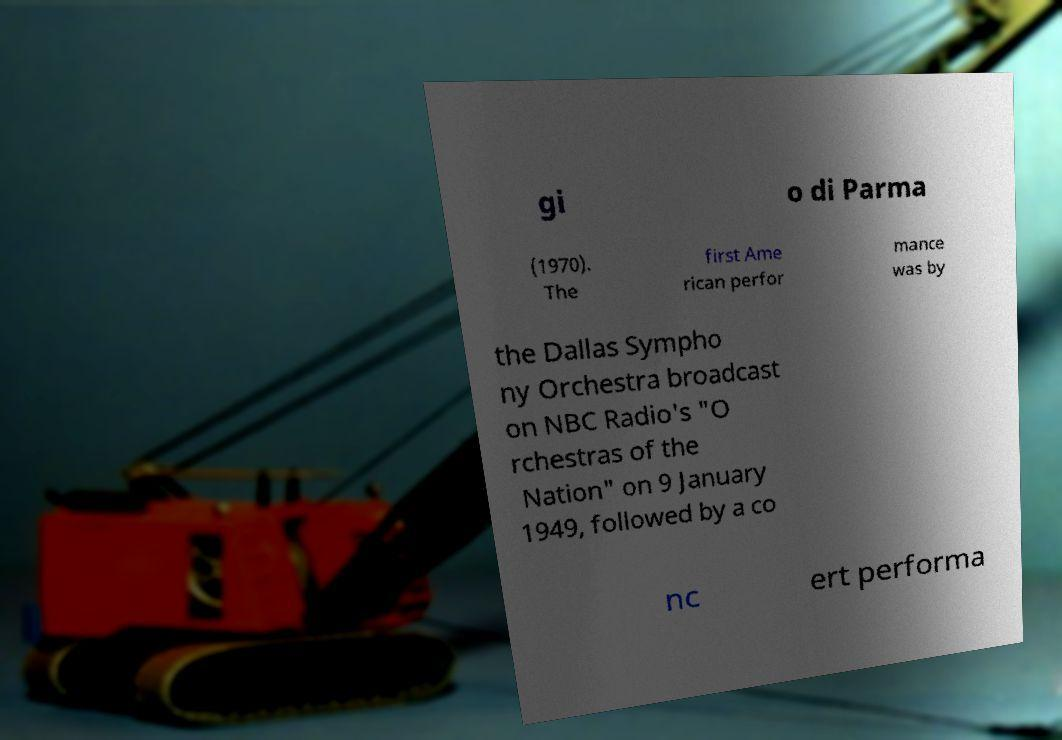Can you read and provide the text displayed in the image?This photo seems to have some interesting text. Can you extract and type it out for me? gi o di Parma (1970). The first Ame rican perfor mance was by the Dallas Sympho ny Orchestra broadcast on NBC Radio's "O rchestras of the Nation" on 9 January 1949, followed by a co nc ert performa 